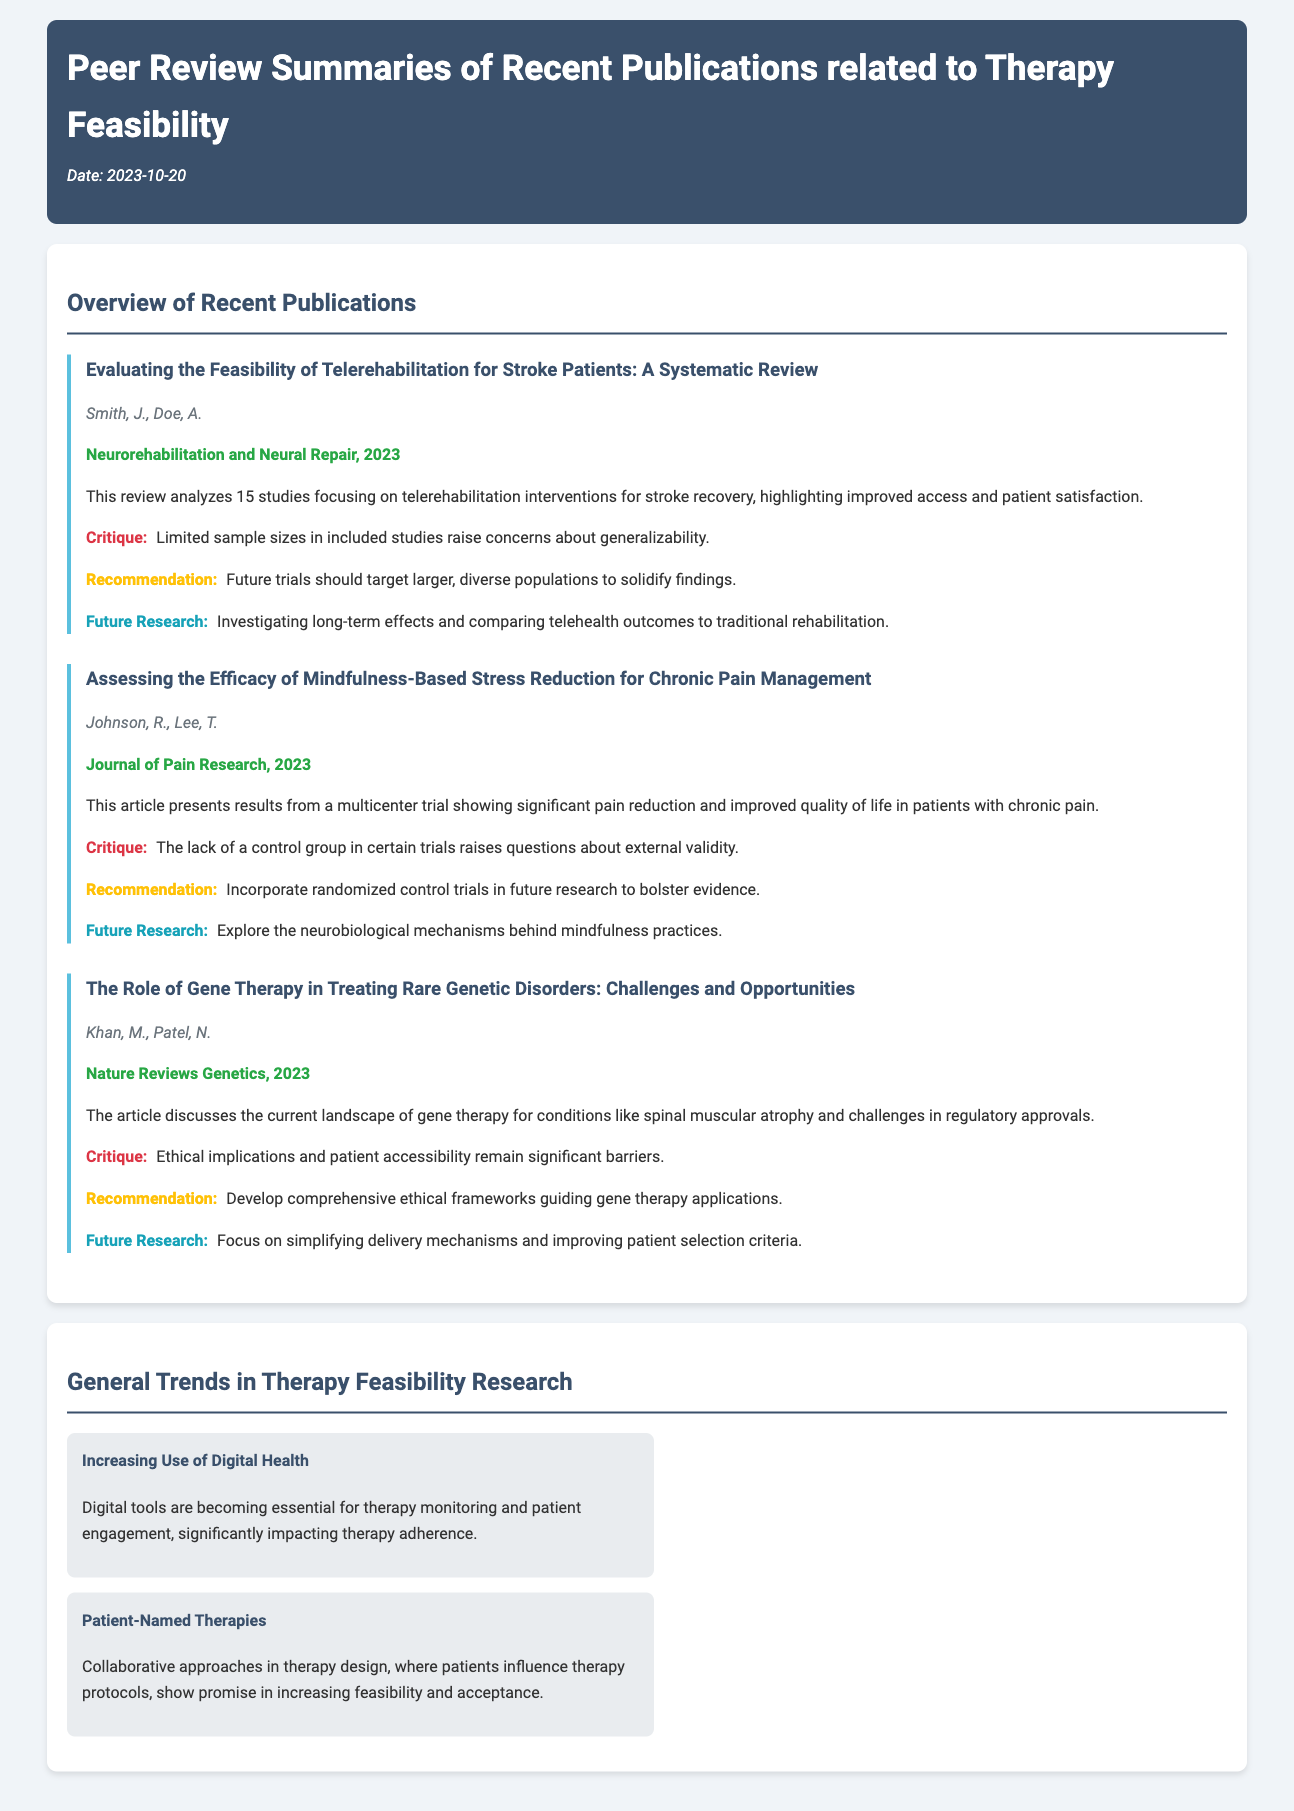What is the title of the first publication? The first publication is specifically titled "Evaluating the Feasibility of Telerehabilitation for Stroke Patients: A Systematic Review."
Answer: Evaluating the Feasibility of Telerehabilitation for Stroke Patients: A Systematic Review Who are the authors of the second publication? The authors of the second publication are Johnson, R. and Lee, T.
Answer: Johnson, R., Lee, T In which journal was the third publication published? The third publication was published in "Nature Reviews Genetics."
Answer: Nature Reviews Genetics What is the critique mentioned for the first publication? The critique for the first publication mentions limited sample sizes in included studies raise concerns about generalizability.
Answer: Limited sample sizes in included studies raise concerns about generalizability What common trend is noted in therapy feasibility research? The trend noted is "Increasing Use of Digital Health."
Answer: Increasing Use of Digital Health What is the publication year of the articles discussed? All the articles discussed in the document are from the year 2023.
Answer: 2023 What recommendation is made in the publication about mindfulness-based stress reduction? The recommendation is to incorporate randomized control trials in future research to bolster evidence.
Answer: Incorporate randomized control trials in future research to bolster evidence Which publication discusses ethical implications? The publication that discusses ethical implications is "The Role of Gene Therapy in Treating Rare Genetic Disorders: Challenges and Opportunities."
Answer: The Role of Gene Therapy in Treating Rare Genetic Disorders: Challenges and Opportunities 